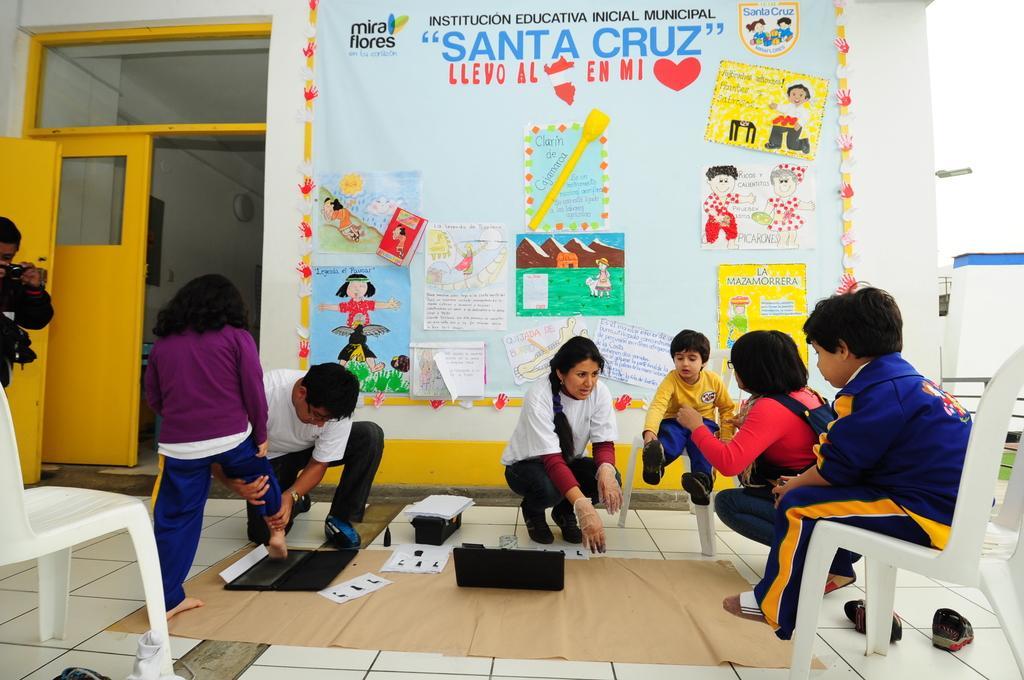Could you give a brief overview of what you see in this image? Here we can see few are sitting on the chairs and few are sitting on the floor. This is mat and there are laptops. Here we can see a person standing on the floor. And he is taking a snap with the camera. This is wall and there are posters. And there is a door. 